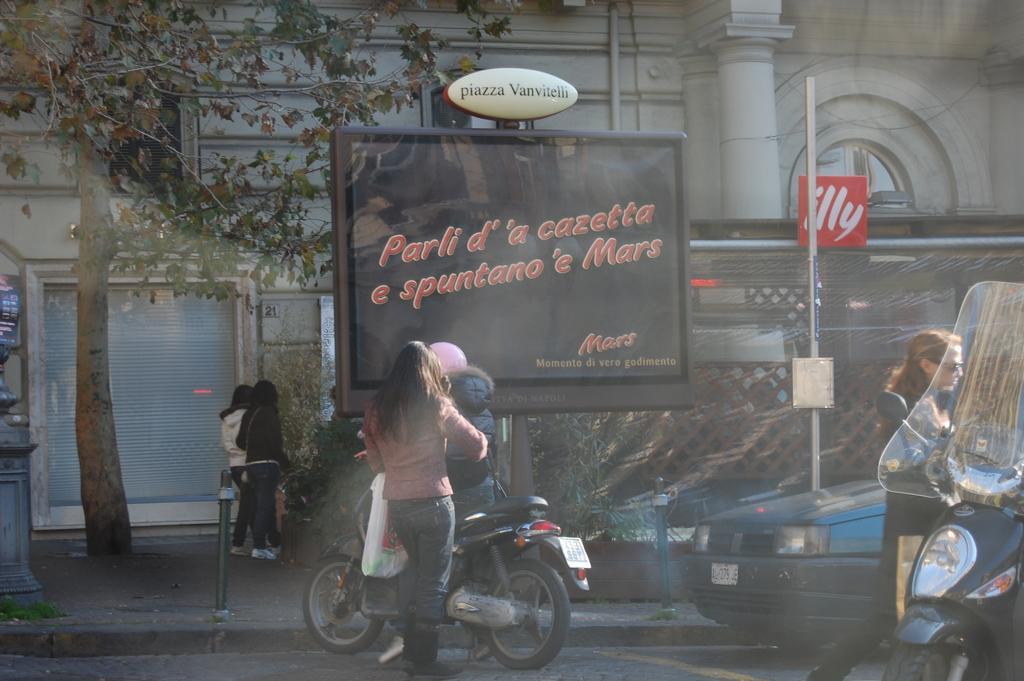Can you describe this image briefly? In this image, at the middle there is a person sitting on the bike, there is a woman she is standing and holding a white color carry bag, at the right side there is a black color bike and there is a car, there is a woman, she is walking, there is a pole, at the middle there is a black color display, there are two persons standing on the path, there is a tree at the left side. 